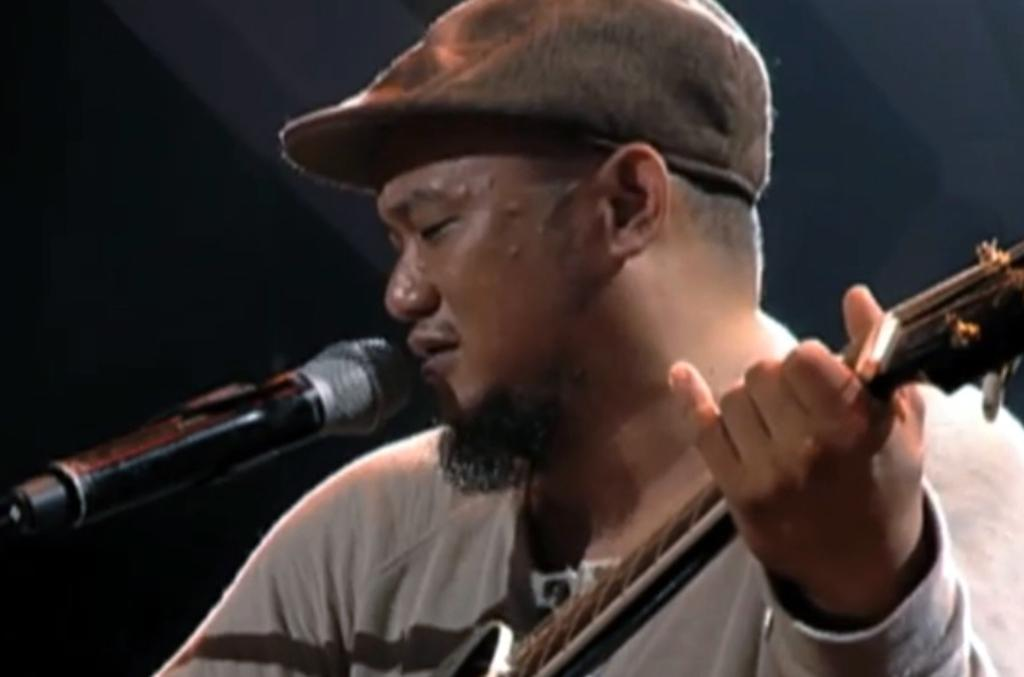Who is the main subject in the image? There is a man in the image. What is the man doing in the image? The man is playing a guitar. What object is in front of the man? There is a microphone in front of the man. What can be observed about the background of the image? The background of the image is dark. What type of operation is the man performing on the guitar in the image? The man is not performing any operation on the guitar; he is playing it. Can you see the man pushing the microphone in the image? There is no indication that the man is pushing the microphone in the image. 